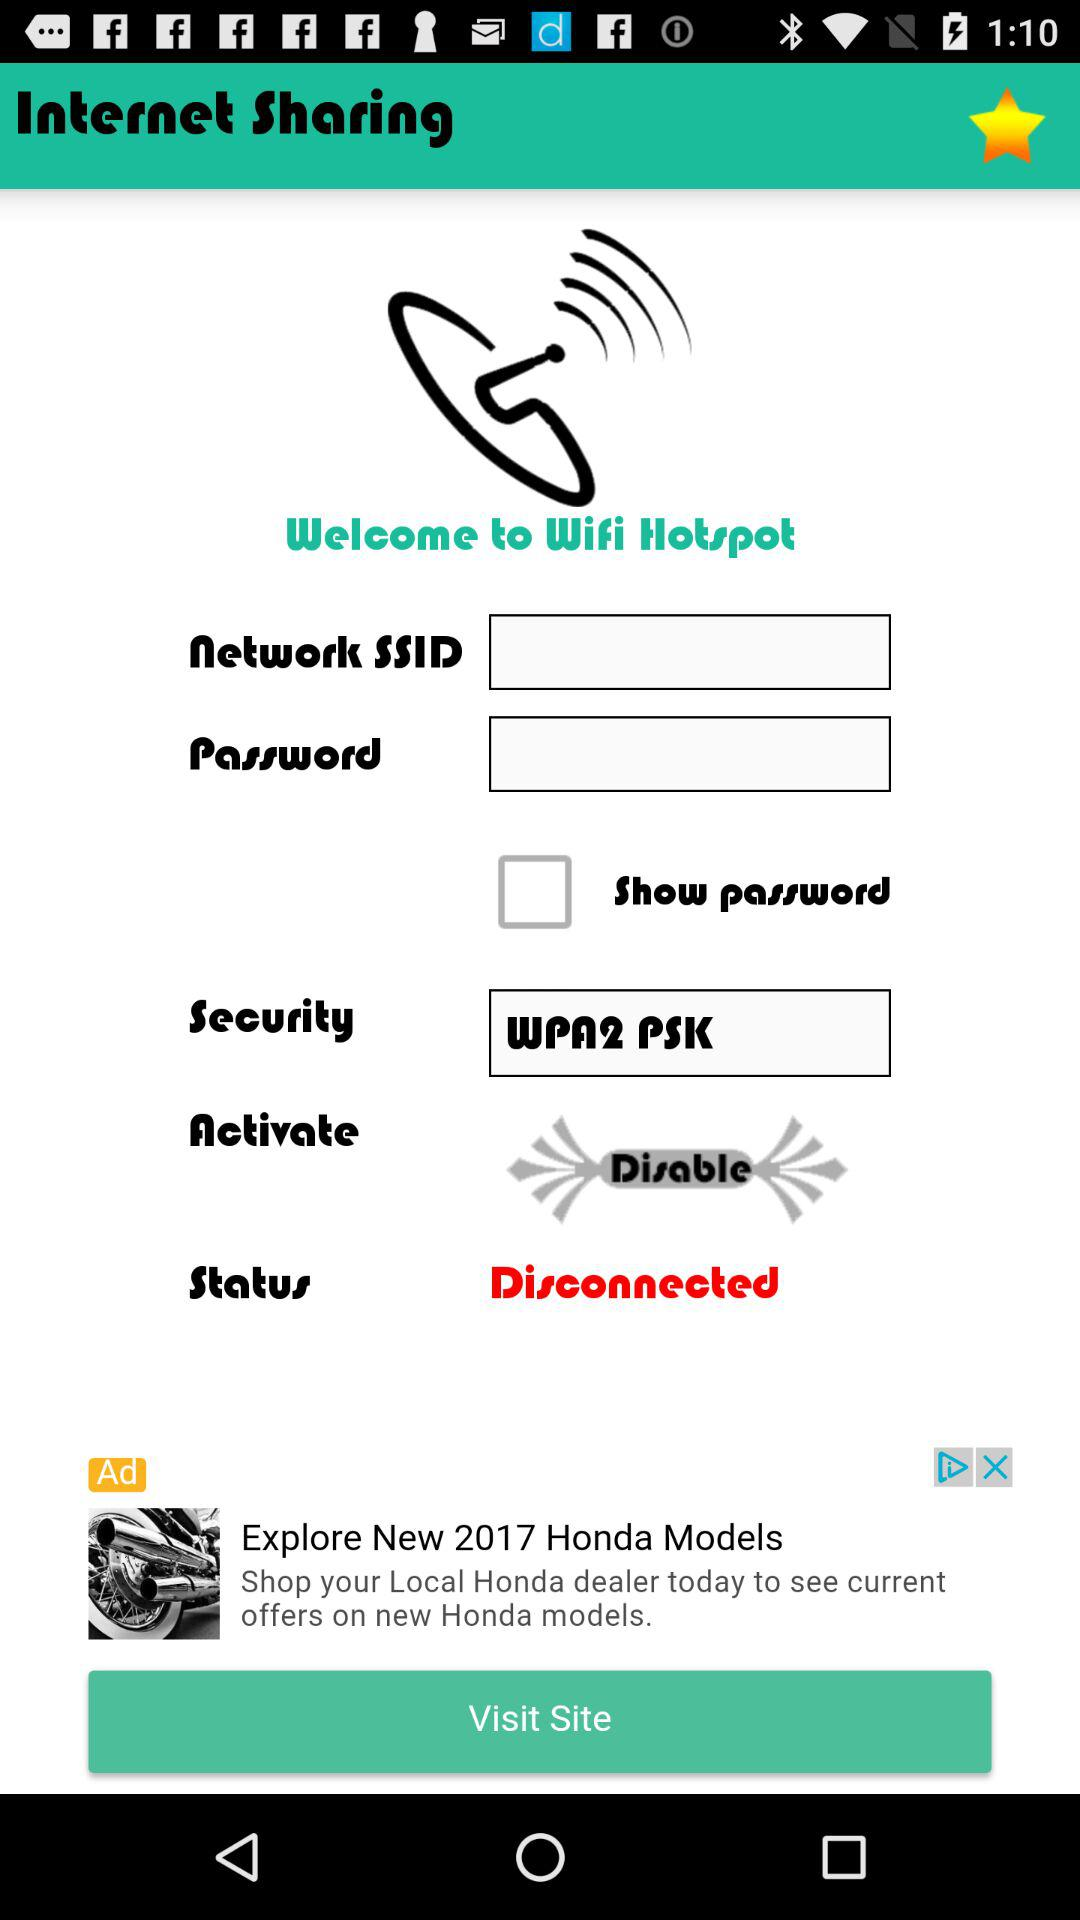What is the security key? The security key is "WPA2 PSK". 